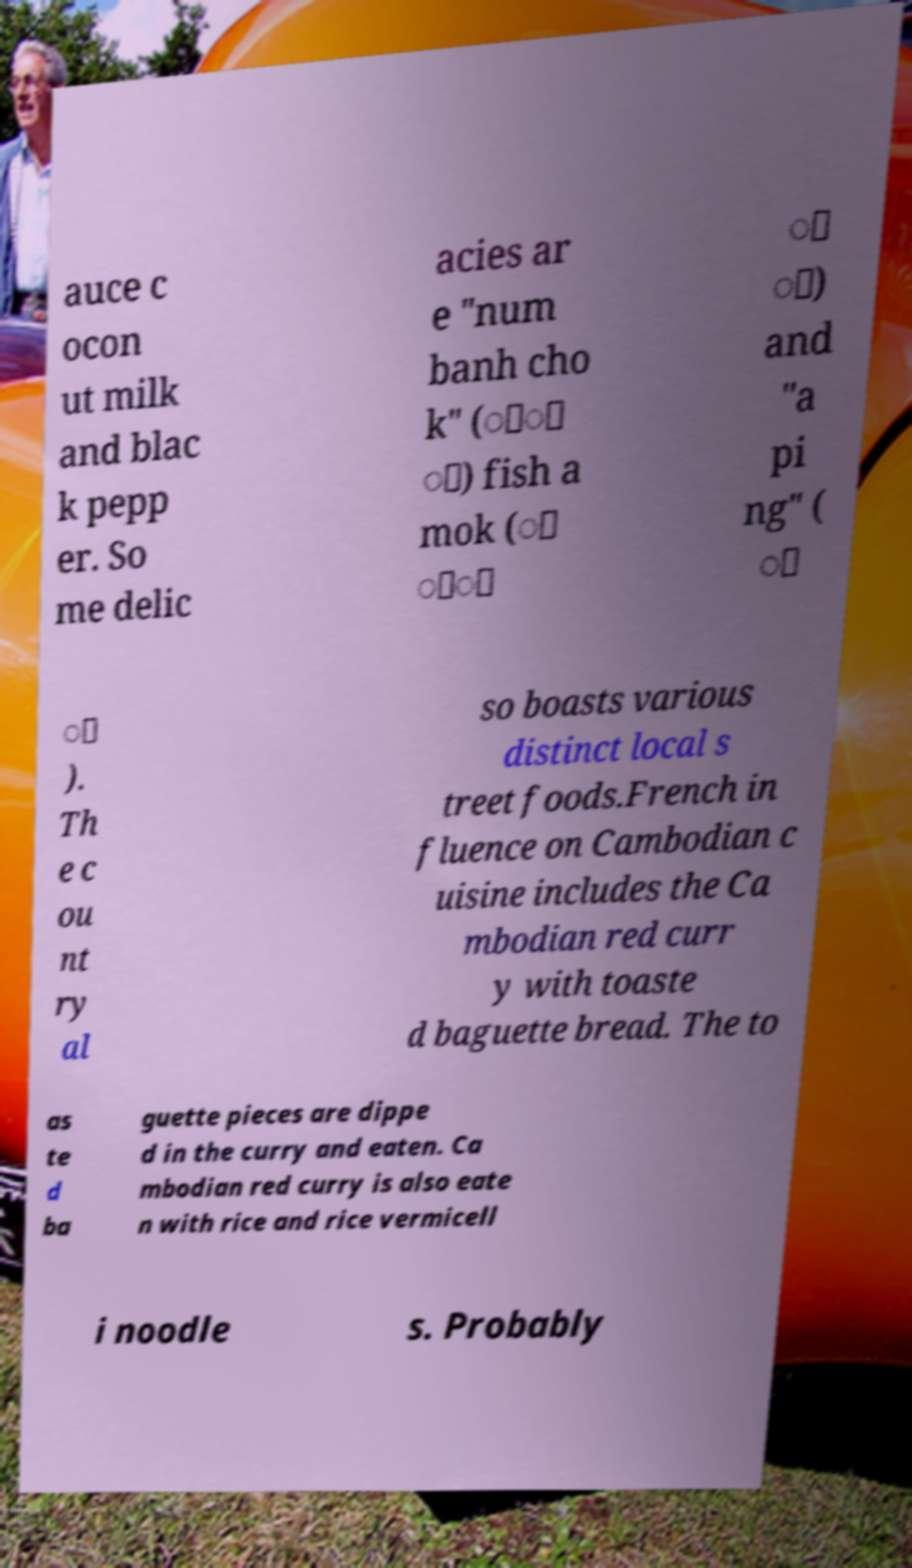For documentation purposes, I need the text within this image transcribed. Could you provide that? auce c ocon ut milk and blac k pepp er. So me delic acies ar e "num banh cho k" (ំ្ ុ) fish a mok (ា ៉ុ ្ ី) and "a pi ng" ( ា ី ). Th e c ou nt ry al so boasts various distinct local s treet foods.French in fluence on Cambodian c uisine includes the Ca mbodian red curr y with toaste d baguette bread. The to as te d ba guette pieces are dippe d in the curry and eaten. Ca mbodian red curry is also eate n with rice and rice vermicell i noodle s. Probably 